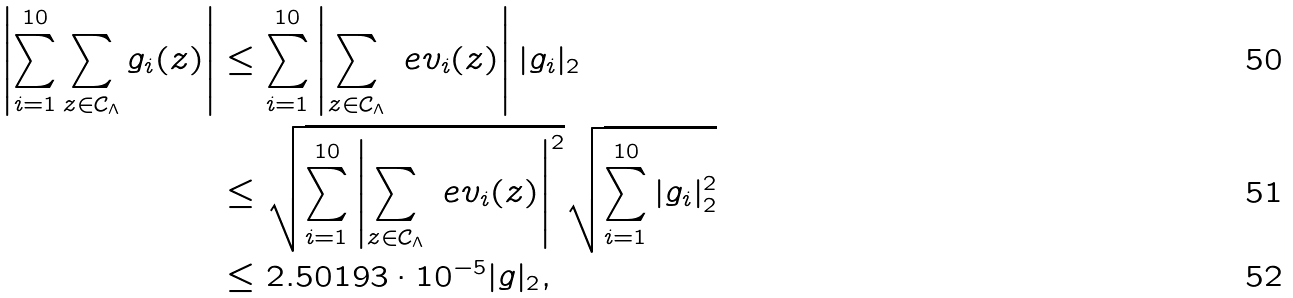Convert formula to latex. <formula><loc_0><loc_0><loc_500><loc_500>\left | \sum _ { i = 1 } ^ { 1 0 } \sum _ { z \in \mathcal { C } _ { \Lambda } } g _ { i } ( z ) \right | & \leq \sum _ { i = 1 } ^ { 1 0 } \left | \sum _ { z \in \mathcal { C } _ { \Lambda } } \ e v _ { i } ( z ) \right | | g _ { i } | _ { 2 } \\ & \leq \sqrt { \sum _ { i = 1 } ^ { 1 0 } \left | \sum _ { z \in \mathcal { C } _ { \Lambda } } \ e v _ { i } ( z ) \right | ^ { 2 } } \sqrt { \sum _ { i = 1 } ^ { 1 0 } | g _ { i } | _ { 2 } ^ { 2 } } \\ \ & \leq 2 . 5 0 1 9 3 \cdot 1 0 ^ { - 5 } | g | _ { 2 } ,</formula> 